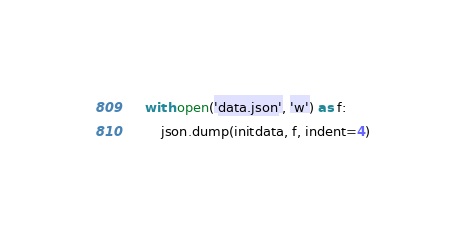<code> <loc_0><loc_0><loc_500><loc_500><_Python_>    with open('data.json', 'w') as f:
        json.dump(initdata, f, indent=4)</code> 